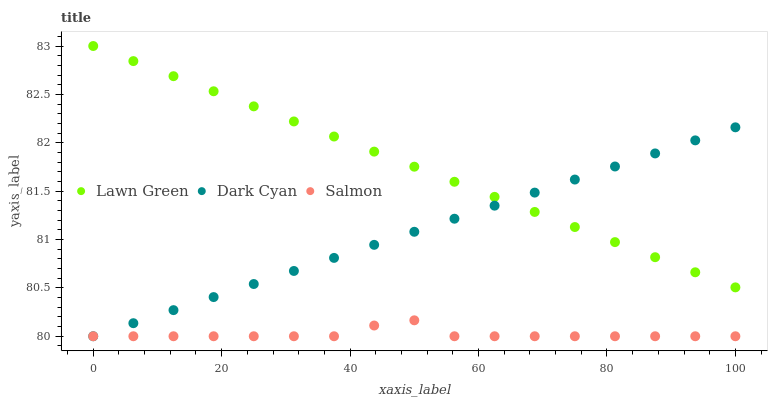Does Salmon have the minimum area under the curve?
Answer yes or no. Yes. Does Lawn Green have the maximum area under the curve?
Answer yes or no. Yes. Does Lawn Green have the minimum area under the curve?
Answer yes or no. No. Does Salmon have the maximum area under the curve?
Answer yes or no. No. Is Dark Cyan the smoothest?
Answer yes or no. Yes. Is Salmon the roughest?
Answer yes or no. Yes. Is Lawn Green the smoothest?
Answer yes or no. No. Is Lawn Green the roughest?
Answer yes or no. No. Does Dark Cyan have the lowest value?
Answer yes or no. Yes. Does Lawn Green have the lowest value?
Answer yes or no. No. Does Lawn Green have the highest value?
Answer yes or no. Yes. Does Salmon have the highest value?
Answer yes or no. No. Is Salmon less than Lawn Green?
Answer yes or no. Yes. Is Lawn Green greater than Salmon?
Answer yes or no. Yes. Does Dark Cyan intersect Salmon?
Answer yes or no. Yes. Is Dark Cyan less than Salmon?
Answer yes or no. No. Is Dark Cyan greater than Salmon?
Answer yes or no. No. Does Salmon intersect Lawn Green?
Answer yes or no. No. 